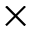<formula> <loc_0><loc_0><loc_500><loc_500>\times</formula> 